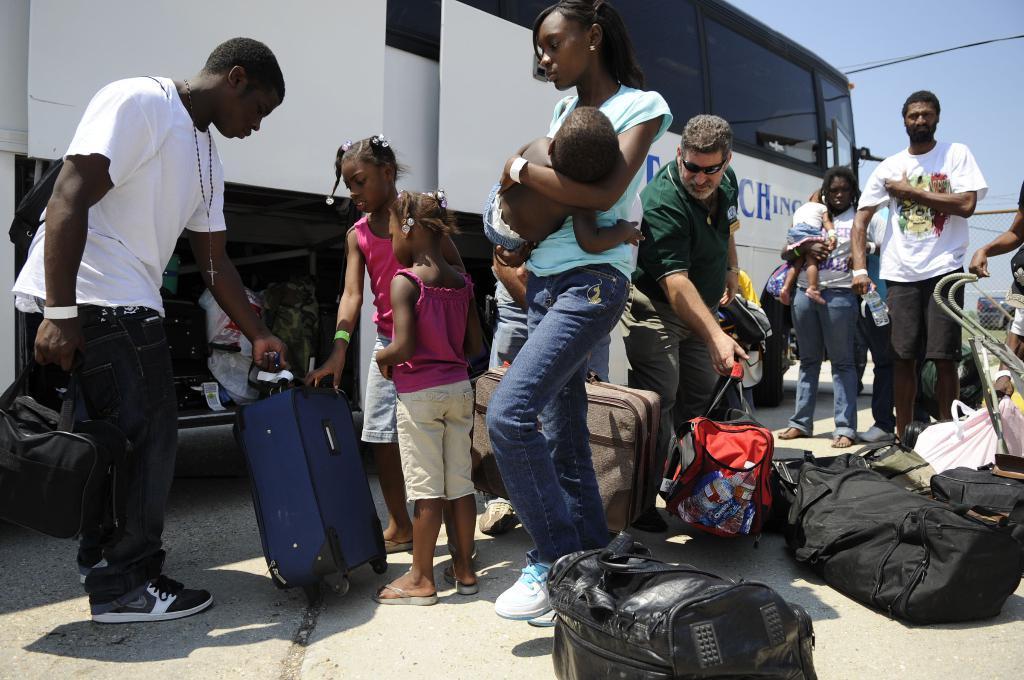How would you summarize this image in a sentence or two? In this image there are so many people standing in front of the bus with their luggage on the floor. In the background there is a sky. 